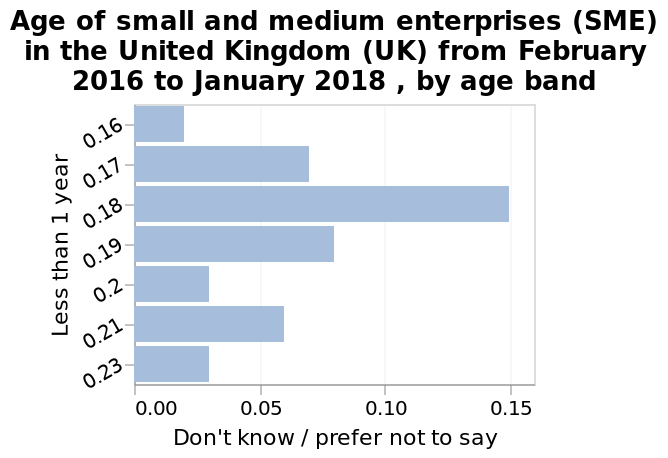<image>
Which values were consistent with a big increase?  The values 0.17 and 0.19 were consistent with a big increase. What is the label of the x-axis on the bar graph?  The x-axis on the bar graph is labeled "Don't know / prefer not to say" and ranges from 0.00 to 0.15. What were the lowest values?  The lowest values were 0.16 and 0.23. How does 0.18 compare to the other values? 0.18 experienced a big increase compared to the other values. What is the label of the y-axis on the bar graph?  The y-axis on the bar graph is labeled "Age of small and medium enterprises (SME) in the United Kingdom (UK) from February 2016 to January 2018, by age band." 